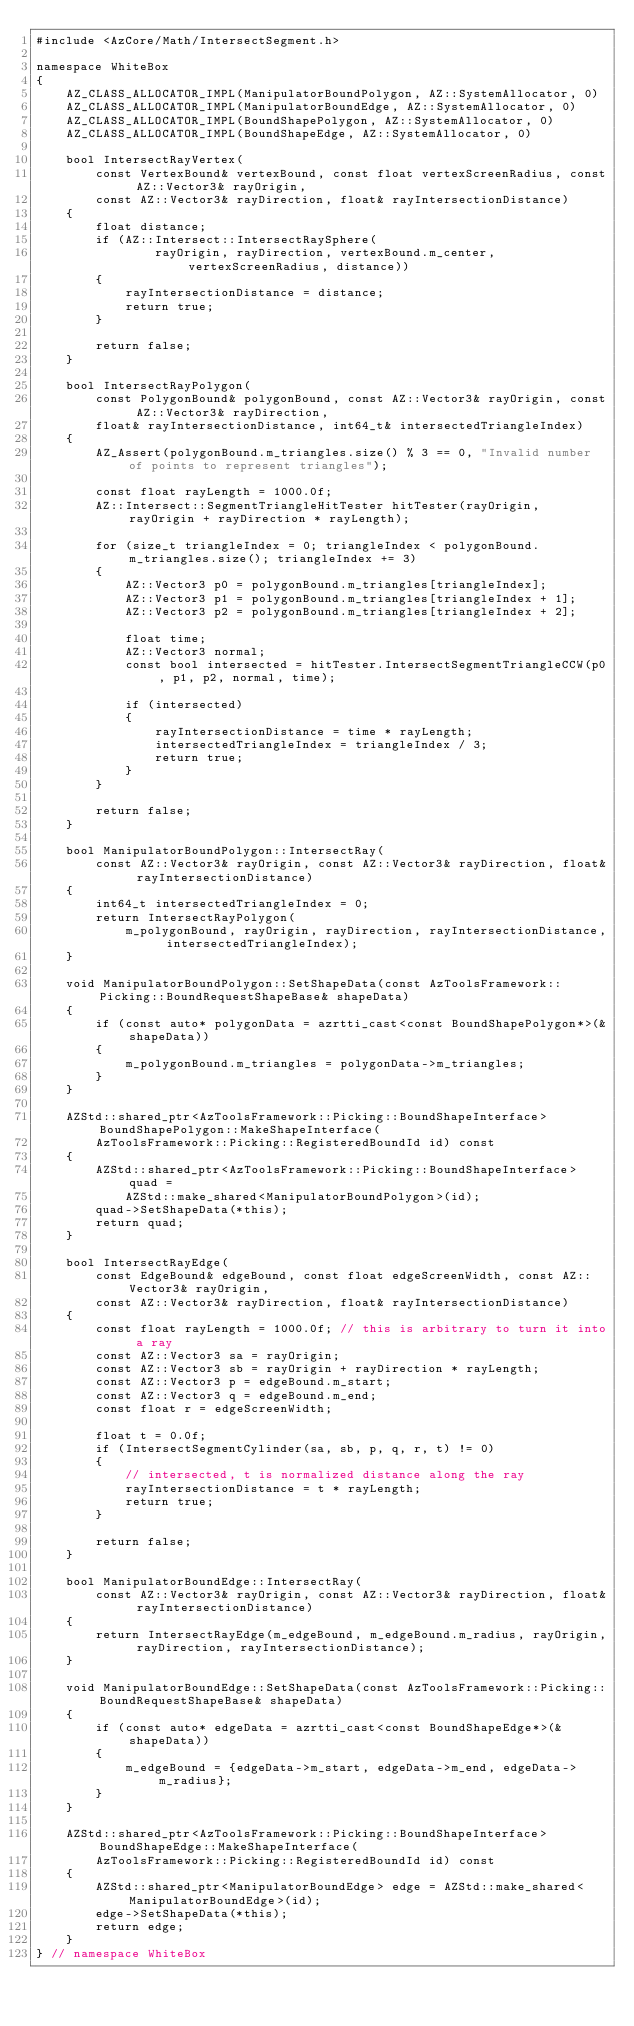<code> <loc_0><loc_0><loc_500><loc_500><_C++_>#include <AzCore/Math/IntersectSegment.h>

namespace WhiteBox
{
    AZ_CLASS_ALLOCATOR_IMPL(ManipulatorBoundPolygon, AZ::SystemAllocator, 0)
    AZ_CLASS_ALLOCATOR_IMPL(ManipulatorBoundEdge, AZ::SystemAllocator, 0)
    AZ_CLASS_ALLOCATOR_IMPL(BoundShapePolygon, AZ::SystemAllocator, 0)
    AZ_CLASS_ALLOCATOR_IMPL(BoundShapeEdge, AZ::SystemAllocator, 0)

    bool IntersectRayVertex(
        const VertexBound& vertexBound, const float vertexScreenRadius, const AZ::Vector3& rayOrigin,
        const AZ::Vector3& rayDirection, float& rayIntersectionDistance)
    {
        float distance;
        if (AZ::Intersect::IntersectRaySphere(
                rayOrigin, rayDirection, vertexBound.m_center, vertexScreenRadius, distance))
        {
            rayIntersectionDistance = distance;
            return true;
        }

        return false;
    }

    bool IntersectRayPolygon(
        const PolygonBound& polygonBound, const AZ::Vector3& rayOrigin, const AZ::Vector3& rayDirection,
        float& rayIntersectionDistance, int64_t& intersectedTriangleIndex)
    {
        AZ_Assert(polygonBound.m_triangles.size() % 3 == 0, "Invalid number of points to represent triangles");

        const float rayLength = 1000.0f;
        AZ::Intersect::SegmentTriangleHitTester hitTester(rayOrigin, rayOrigin + rayDirection * rayLength);

        for (size_t triangleIndex = 0; triangleIndex < polygonBound.m_triangles.size(); triangleIndex += 3)
        {
            AZ::Vector3 p0 = polygonBound.m_triangles[triangleIndex];
            AZ::Vector3 p1 = polygonBound.m_triangles[triangleIndex + 1];
            AZ::Vector3 p2 = polygonBound.m_triangles[triangleIndex + 2];

            float time;
            AZ::Vector3 normal;
            const bool intersected = hitTester.IntersectSegmentTriangleCCW(p0, p1, p2, normal, time);

            if (intersected)
            {
                rayIntersectionDistance = time * rayLength;
                intersectedTriangleIndex = triangleIndex / 3;
                return true;
            }
        }

        return false;
    }

    bool ManipulatorBoundPolygon::IntersectRay(
        const AZ::Vector3& rayOrigin, const AZ::Vector3& rayDirection, float& rayIntersectionDistance)
    {
        int64_t intersectedTriangleIndex = 0;
        return IntersectRayPolygon(
            m_polygonBound, rayOrigin, rayDirection, rayIntersectionDistance, intersectedTriangleIndex);
    }

    void ManipulatorBoundPolygon::SetShapeData(const AzToolsFramework::Picking::BoundRequestShapeBase& shapeData)
    {
        if (const auto* polygonData = azrtti_cast<const BoundShapePolygon*>(&shapeData))
        {
            m_polygonBound.m_triangles = polygonData->m_triangles;
        }
    }

    AZStd::shared_ptr<AzToolsFramework::Picking::BoundShapeInterface> BoundShapePolygon::MakeShapeInterface(
        AzToolsFramework::Picking::RegisteredBoundId id) const
    {
        AZStd::shared_ptr<AzToolsFramework::Picking::BoundShapeInterface> quad =
            AZStd::make_shared<ManipulatorBoundPolygon>(id);
        quad->SetShapeData(*this);
        return quad;
    }

    bool IntersectRayEdge(
        const EdgeBound& edgeBound, const float edgeScreenWidth, const AZ::Vector3& rayOrigin,
        const AZ::Vector3& rayDirection, float& rayIntersectionDistance)
    {
        const float rayLength = 1000.0f; // this is arbitrary to turn it into a ray
        const AZ::Vector3 sa = rayOrigin;
        const AZ::Vector3 sb = rayOrigin + rayDirection * rayLength;
        const AZ::Vector3 p = edgeBound.m_start;
        const AZ::Vector3 q = edgeBound.m_end;
        const float r = edgeScreenWidth;

        float t = 0.0f;
        if (IntersectSegmentCylinder(sa, sb, p, q, r, t) != 0)
        {
            // intersected, t is normalized distance along the ray
            rayIntersectionDistance = t * rayLength;
            return true;
        }

        return false;
    }

    bool ManipulatorBoundEdge::IntersectRay(
        const AZ::Vector3& rayOrigin, const AZ::Vector3& rayDirection, float& rayIntersectionDistance)
    {
        return IntersectRayEdge(m_edgeBound, m_edgeBound.m_radius, rayOrigin, rayDirection, rayIntersectionDistance);
    }

    void ManipulatorBoundEdge::SetShapeData(const AzToolsFramework::Picking::BoundRequestShapeBase& shapeData)
    {
        if (const auto* edgeData = azrtti_cast<const BoundShapeEdge*>(&shapeData))
        {
            m_edgeBound = {edgeData->m_start, edgeData->m_end, edgeData->m_radius};
        }
    }

    AZStd::shared_ptr<AzToolsFramework::Picking::BoundShapeInterface> BoundShapeEdge::MakeShapeInterface(
        AzToolsFramework::Picking::RegisteredBoundId id) const
    {
        AZStd::shared_ptr<ManipulatorBoundEdge> edge = AZStd::make_shared<ManipulatorBoundEdge>(id);
        edge->SetShapeData(*this);
        return edge;
    }
} // namespace WhiteBox
</code> 